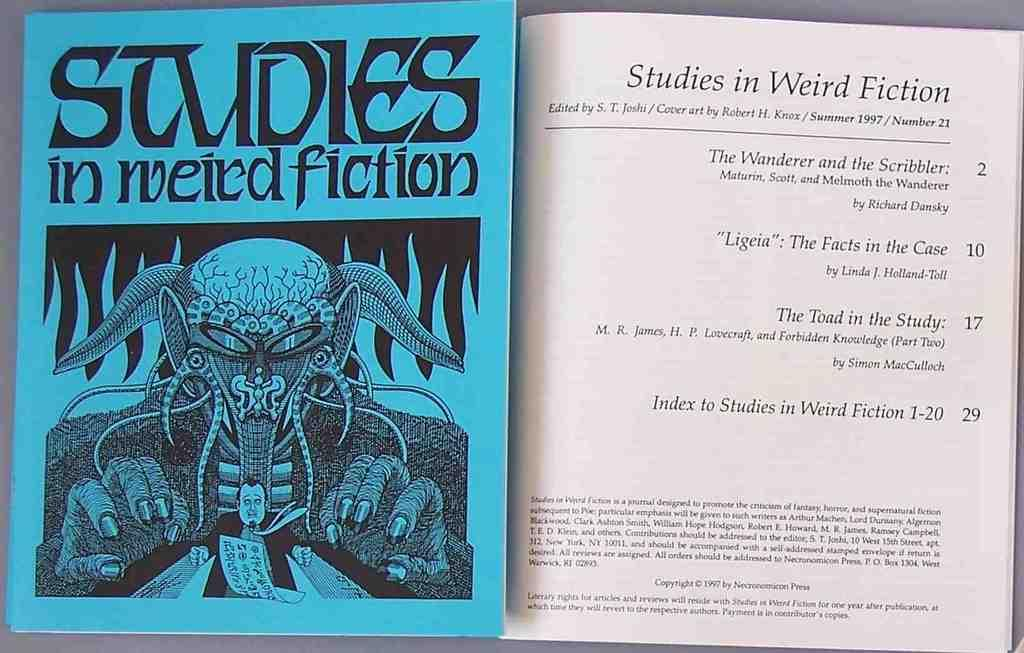<image>
Create a compact narrative representing the image presented. A blue book cover titled Studies in Weird Fiction. 